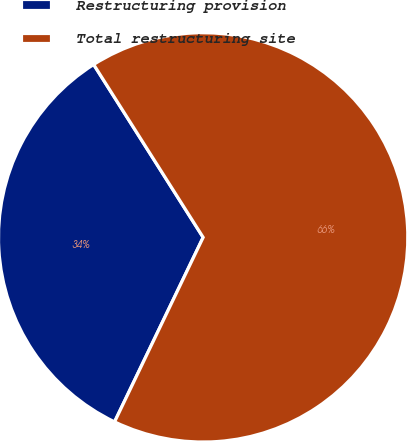Convert chart. <chart><loc_0><loc_0><loc_500><loc_500><pie_chart><fcel>Restructuring provision<fcel>Total restructuring site<nl><fcel>33.89%<fcel>66.11%<nl></chart> 